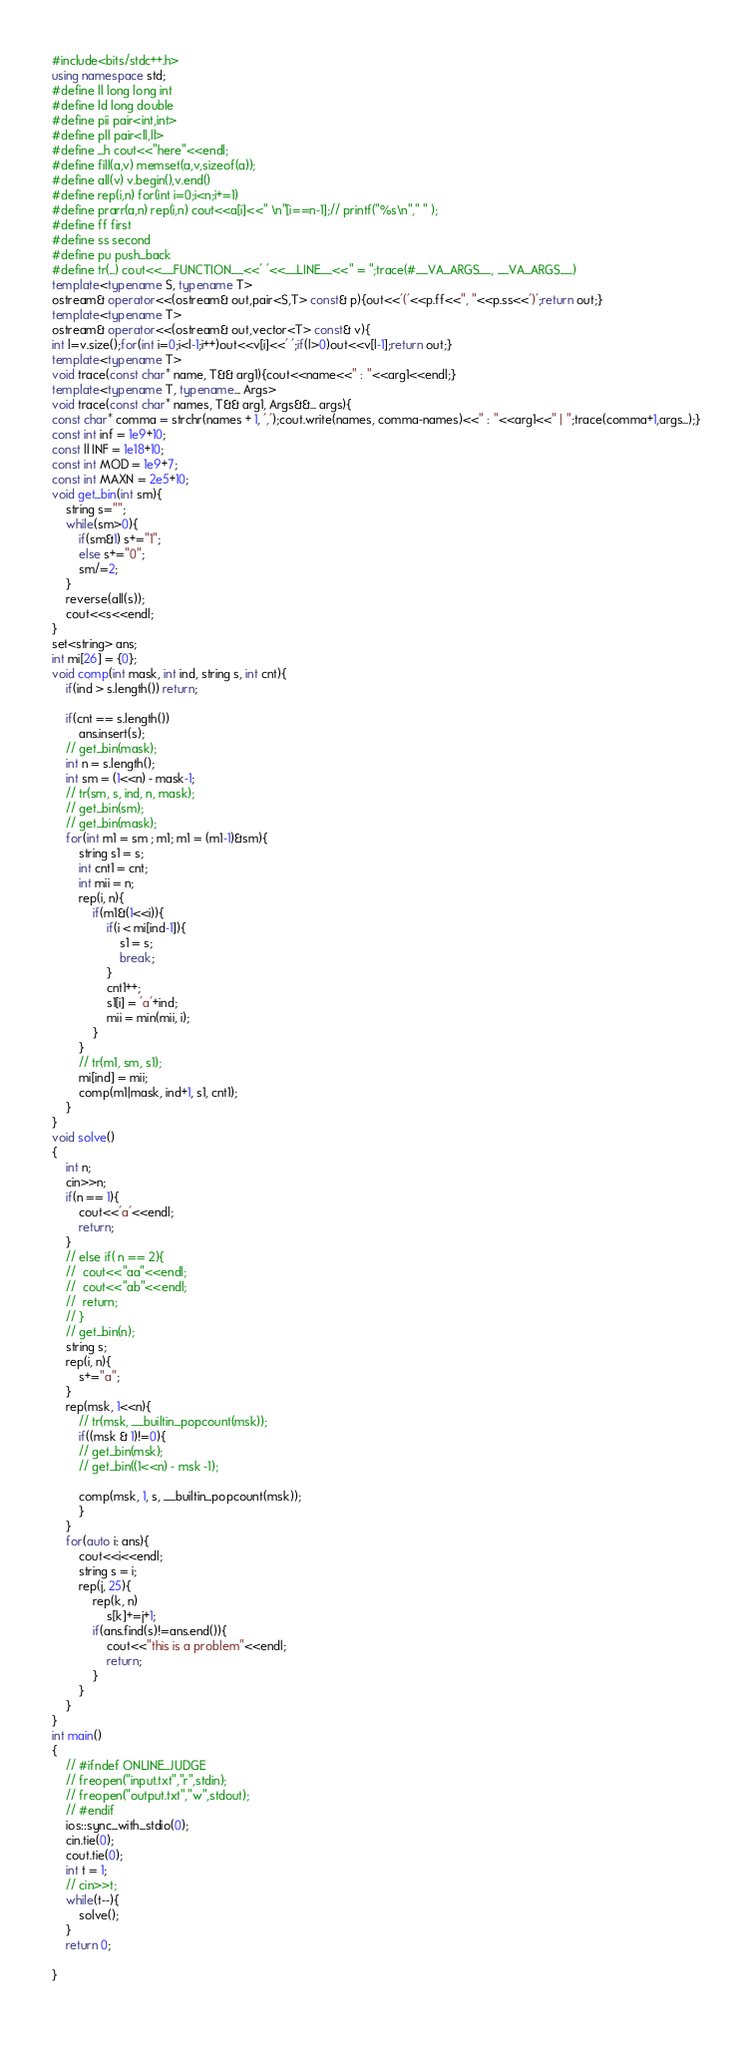Convert code to text. <code><loc_0><loc_0><loc_500><loc_500><_C++_>#include<bits/stdc++.h>
using namespace std;
#define ll long long int
#define ld long double
#define pii pair<int,int>
#define pll pair<ll,ll>
#define _h cout<<"here"<<endl;
#define fill(a,v) memset(a,v,sizeof(a));
#define all(v) v.begin(),v.end()
#define rep(i,n) for(int i=0;i<n;i+=1)
#define prarr(a,n) rep(i,n) cout<<a[i]<<" \n"[i==n-1];// printf("%s\n"," " );
#define ff first
#define ss second
#define pu push_back
#define tr(...) cout<<__FUNCTION__<<' '<<__LINE__<<" = ";trace(#__VA_ARGS__, __VA_ARGS__)
template<typename S, typename T> 
ostream& operator<<(ostream& out,pair<S,T> const& p){out<<'('<<p.ff<<", "<<p.ss<<')';return out;}
template<typename T>
ostream& operator<<(ostream& out,vector<T> const& v){
int l=v.size();for(int i=0;i<l-1;i++)out<<v[i]<<' ';if(l>0)out<<v[l-1];return out;}
template<typename T>
void trace(const char* name, T&& arg1){cout<<name<<" : "<<arg1<<endl;}
template<typename T, typename... Args>
void trace(const char* names, T&& arg1, Args&&... args){
const char* comma = strchr(names + 1, ',');cout.write(names, comma-names)<<" : "<<arg1<<" | ";trace(comma+1,args...);}
const int inf = 1e9+10;
const ll INF = 1e18+10;
const int MOD = 1e9+7;
const int MAXN = 2e5+10;
void get_bin(int sm){
	string s="";
	while(sm>0){
		if(sm&1) s+="1";
		else s+="0";
		sm/=2;
	}
	reverse(all(s));
	cout<<s<<endl;
}
set<string> ans;
int mi[26] = {0};
void comp(int mask, int ind, string s, int cnt){
	if(ind > s.length()) return;

	if(cnt == s.length())
		ans.insert(s);
	// get_bin(mask);
	int n = s.length();
	int sm = (1<<n) - mask-1;
	// tr(sm, s, ind, n, mask);
	// get_bin(sm);
	// get_bin(mask);
	for(int m1 = sm ; m1; m1 = (m1-1)&sm){
		string s1 = s;
		int cnt1 = cnt;
		int mii = n;
		rep(i, n){
			if(m1&(1<<i)){
				if(i < mi[ind-1]){
					s1 = s;
					break;
				}
				cnt1++;
		    	s1[i] = 'a'+ind;
		    	mii = min(mii, i);
			}
		}
		// tr(m1, sm, s1);
		mi[ind] = mii;
		comp(m1|mask, ind+1, s1, cnt1);
	}
}
void solve()
{
	int n;
	cin>>n;
	if(n == 1){
		cout<<'a'<<endl;
		return;
	}
	// else if( n == 2){
	// 	cout<<"aa"<<endl;
	// 	cout<<"ab"<<endl;
	// 	return;
	// }
	// get_bin(n);
	string s;
	rep(i, n){
		s+="a";
	}
	rep(msk, 1<<n){
		// tr(msk, __builtin_popcount(msk));
		if((msk & 1)!=0){
		// get_bin(msk);
		// get_bin((1<<n) - msk -1);

		comp(msk, 1, s, __builtin_popcount(msk));
		}
	}
	for(auto i: ans){
		cout<<i<<endl;
		string s = i;
		rep(j, 25){
			rep(k, n)
				s[k]+=j+1;
			if(ans.find(s)!=ans.end()){
				cout<<"this is a problem"<<endl;
				return;
			}	
		}
	}
}
int main()
{
	// #ifndef ONLINE_JUDGE
	// freopen("input.txt","r",stdin);
	// freopen("output.txt","w",stdout);
	// #endif
	ios::sync_with_stdio(0);
	cin.tie(0);
	cout.tie(0);
	int t = 1;
	// cin>>t;
	while(t--){
		solve();
	}
	return 0;

}
    </code> 